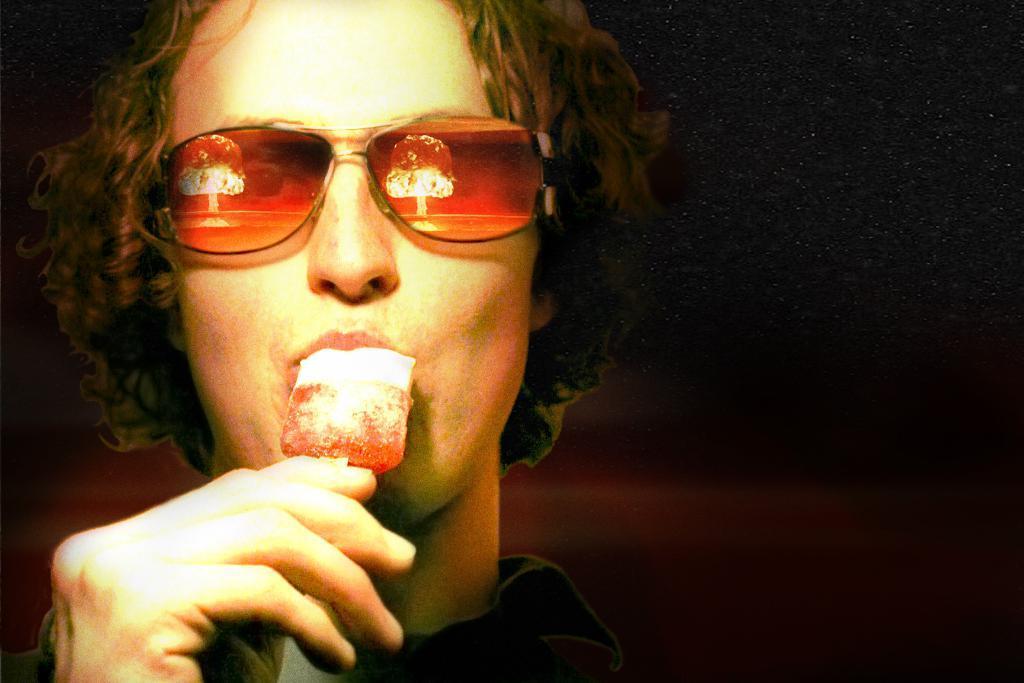Please provide a concise description of this image. In this image we can see a person holding an ice cream and eating. In the background, the image is dark. 